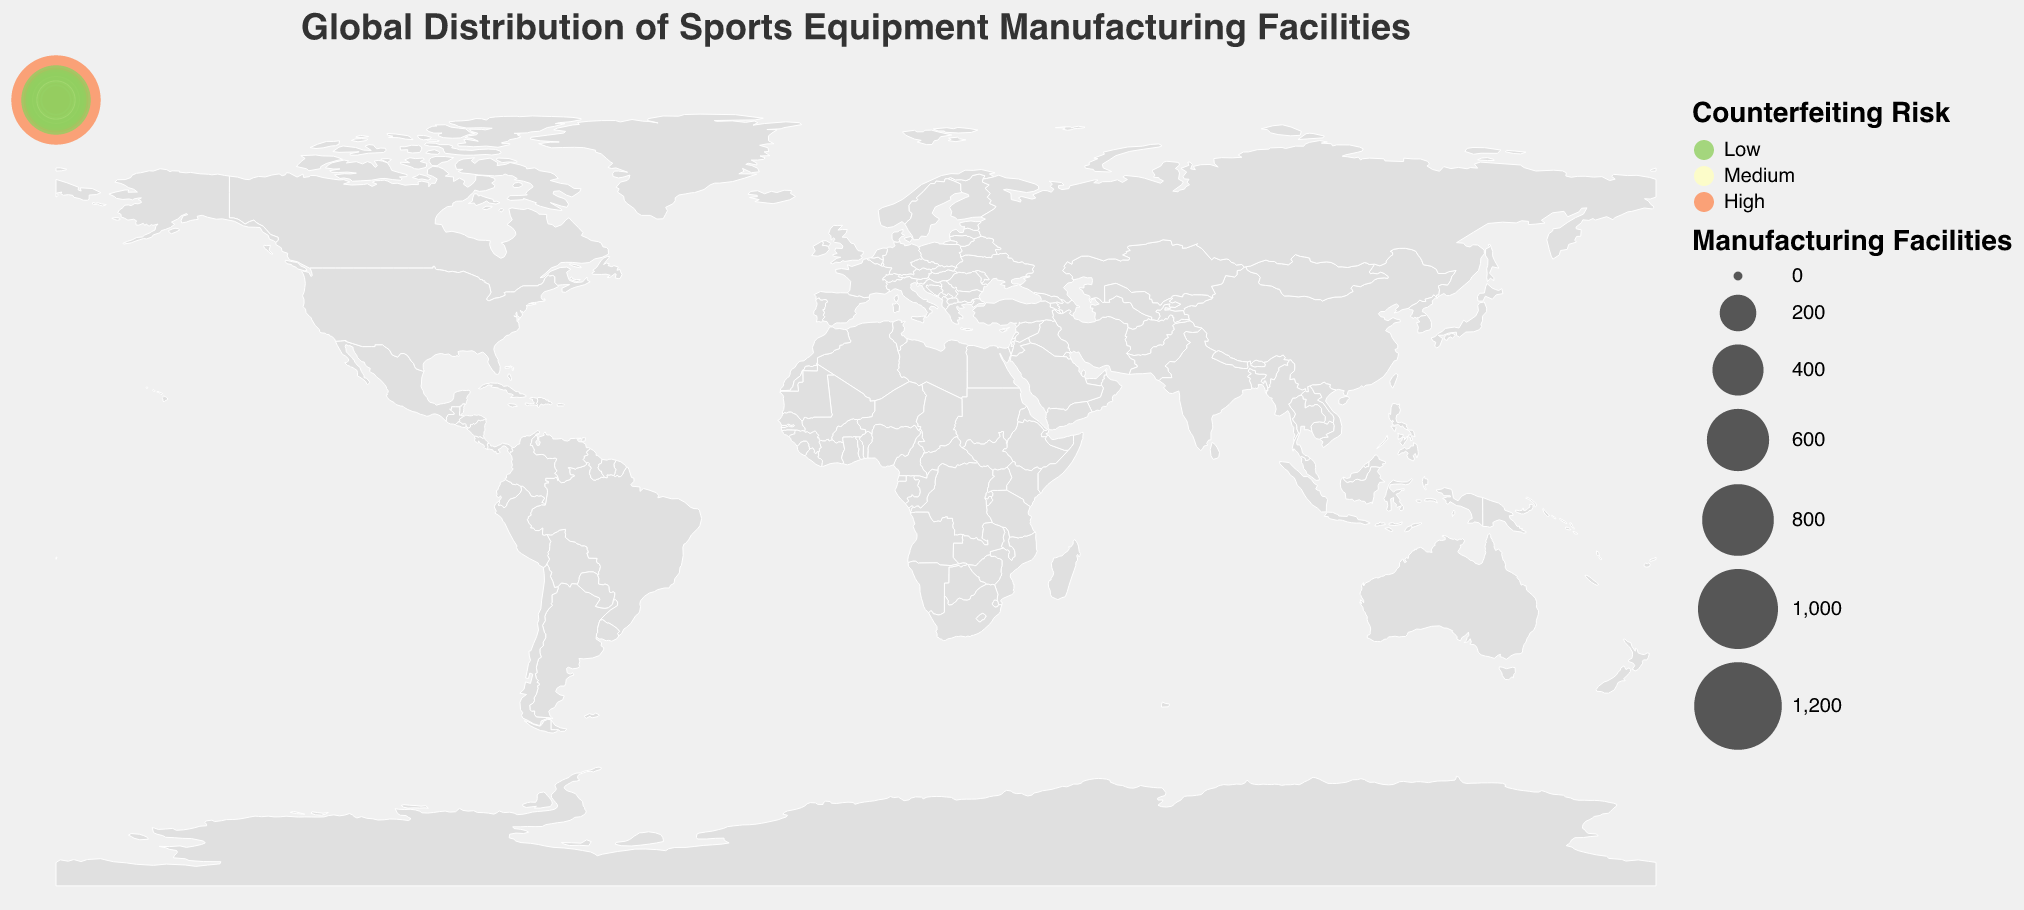What is the title of the figure? The title of the figure is prominently displayed at the top and describes the overall topic of the visualization. It states what the figure is about.
Answer: Global Distribution of Sports Equipment Manufacturing Facilities Which country has the highest number of sports equipment manufacturing facilities? By looking at the size of the circles representing the facilities on the geographic plot, it is noticeable that the largest circle is located in East Asia and corresponds to China.
Answer: China Which countries are marked with a high counterfeiting risk? By observing the color legend that denotes 'High' risk with a certain color, the countries with this color can be listed. These countries are China, India, Pakistan, Thailand, Malaysia, Bangladesh, and Cambodia.
Answer: China, India, Pakistan, Thailand, Malaysia, Bangladesh, Cambodia How many manufacturing facilities are there in Southeast Asia? By summing up the number of manufacturing facilities in the countries within Southeast Asia (Vietnam, Indonesia, Thailand, Malaysia, Philippines, Cambodia), we get 450 + 300 + 220 + 170 + 140 + 90.
Answer: 1370 Which region has the most diverse range of counterfeiting risks? Looking at the plot, by counting the number of different counterfeiting risk colors within regions, Southeast Asia stands out with high, medium, and low-risk countries.
Answer: Southeast Asia Compare the number of manufacturing facilities between East Asia and South Asia. Which region has more? Summing up the facilities in East Asia (China, Taiwan, Japan, South Korea) gives 2550, and summing up in South Asia (India, Pakistan, Bangladesh) gives 960.
Answer: East Asia What is the average number of manufacturing facilities in countries with a low counterfeiting risk? By identifying the countries marked with low risk (United States, Italy, Japan, Germany, South Korea, and Spain) and averaging their facilities: (750 + 420 + 580 + 490 + 320 + 210)/6.
Answer: 461.67 Which country in North America has the higher counterfeiting risk? By reviewing the colors in North America, Mexico is marked with a 'Medium' risk while the United States is marked 'Low'.
Answer: Mexico How does the number of facilities in South America compare to those in South Asia? Summing up the facilities in South America (Brazil) and comparing it to the sum in South Asia (India, Pakistan, Bangladesh). South America has 180 while South Asia has 960.
Answer: South Asia Which region houses the least sports equipment manufacturing facilities according to the data? By summing up the total number of facilities in each region, the region with the smallest total will be identified. Central Europe has only 490 facilities in total.
Answer: Central Europe 